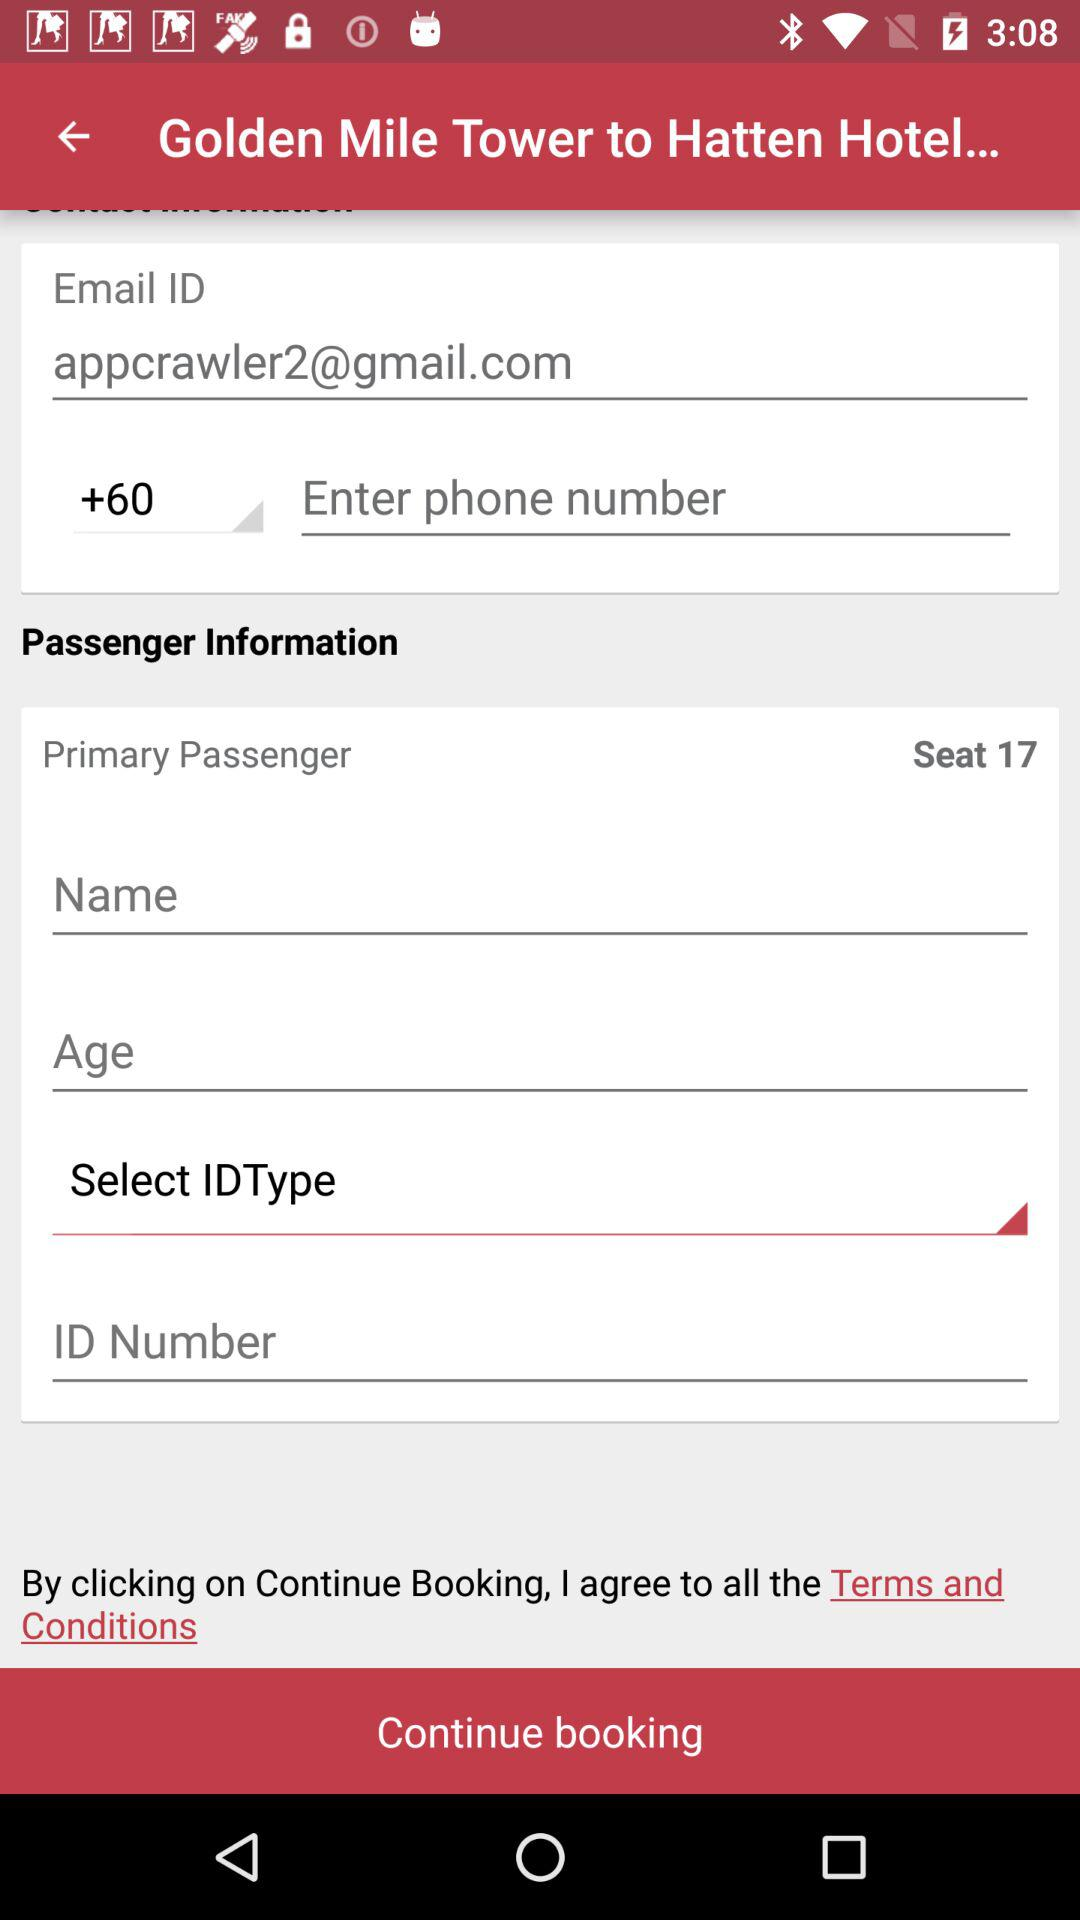How many seats are there in the primary passenger? There are 17 seats. 